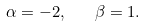Convert formula to latex. <formula><loc_0><loc_0><loc_500><loc_500>\alpha = - 2 , \quad \beta = 1 .</formula> 